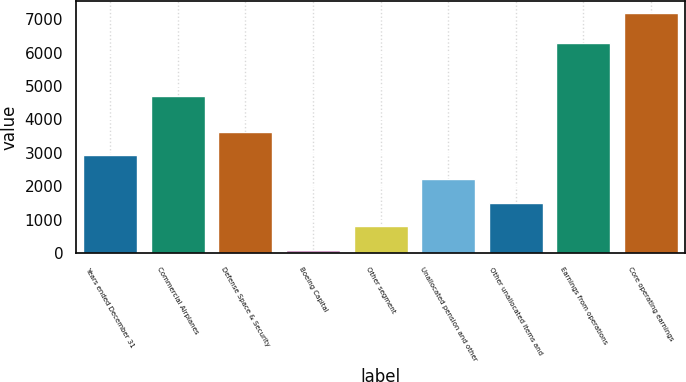Convert chart. <chart><loc_0><loc_0><loc_500><loc_500><bar_chart><fcel>Years ended December 31<fcel>Commercial Airplanes<fcel>Defense Space & Security<fcel>Boeing Capital<fcel>Other segment<fcel>Unallocated pension and other<fcel>Other unallocated items and<fcel>Earnings from operations<fcel>Core operating earnings<nl><fcel>2928.4<fcel>4711<fcel>3638.5<fcel>88<fcel>798.1<fcel>2218.3<fcel>1508.2<fcel>6290<fcel>7189<nl></chart> 